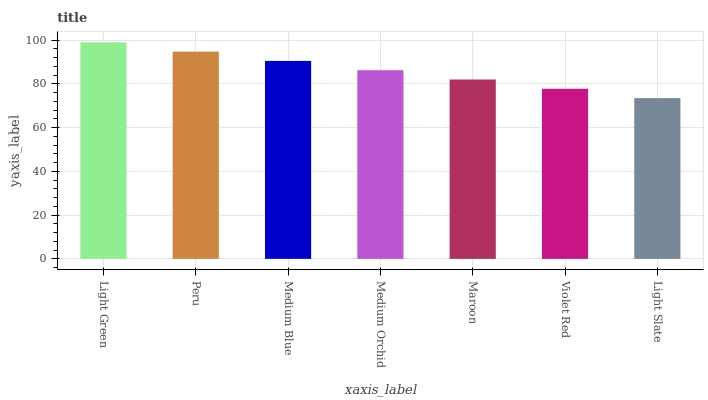Is Light Slate the minimum?
Answer yes or no. Yes. Is Light Green the maximum?
Answer yes or no. Yes. Is Peru the minimum?
Answer yes or no. No. Is Peru the maximum?
Answer yes or no. No. Is Light Green greater than Peru?
Answer yes or no. Yes. Is Peru less than Light Green?
Answer yes or no. Yes. Is Peru greater than Light Green?
Answer yes or no. No. Is Light Green less than Peru?
Answer yes or no. No. Is Medium Orchid the high median?
Answer yes or no. Yes. Is Medium Orchid the low median?
Answer yes or no. Yes. Is Light Slate the high median?
Answer yes or no. No. Is Maroon the low median?
Answer yes or no. No. 